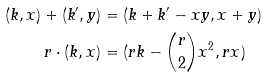<formula> <loc_0><loc_0><loc_500><loc_500>( k , x ) + ( k ^ { \prime } , y ) & = ( k + k ^ { \prime } - x y , x + y ) \\ r \cdot ( k , x ) & = ( r k - \binom { r } { 2 } x ^ { 2 } , r x )</formula> 